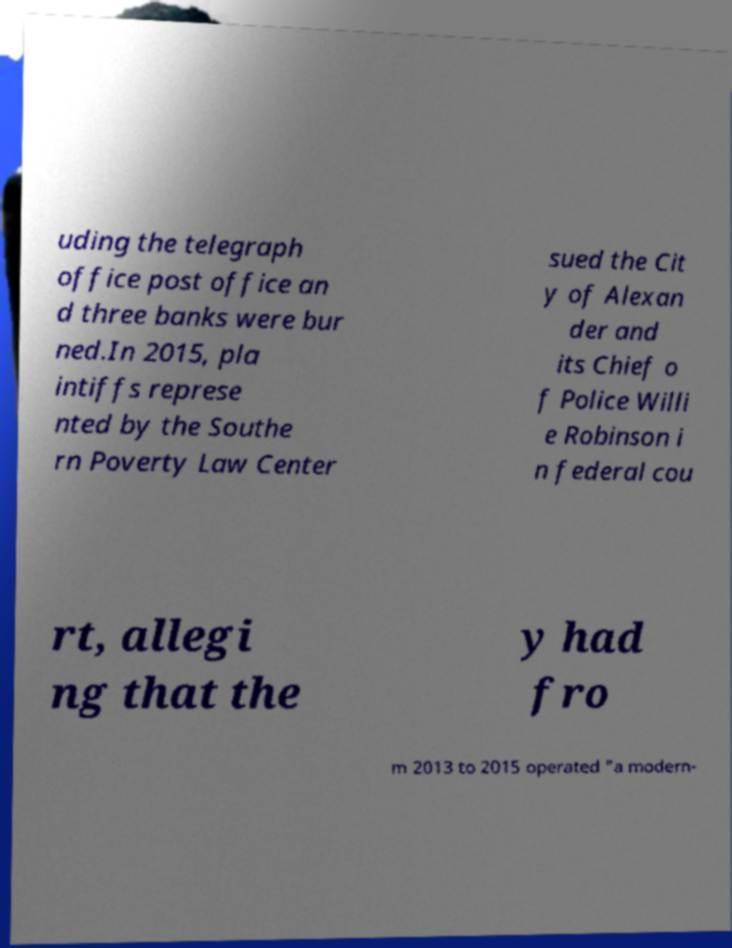Can you accurately transcribe the text from the provided image for me? uding the telegraph office post office an d three banks were bur ned.In 2015, pla intiffs represe nted by the Southe rn Poverty Law Center sued the Cit y of Alexan der and its Chief o f Police Willi e Robinson i n federal cou rt, allegi ng that the y had fro m 2013 to 2015 operated "a modern- 